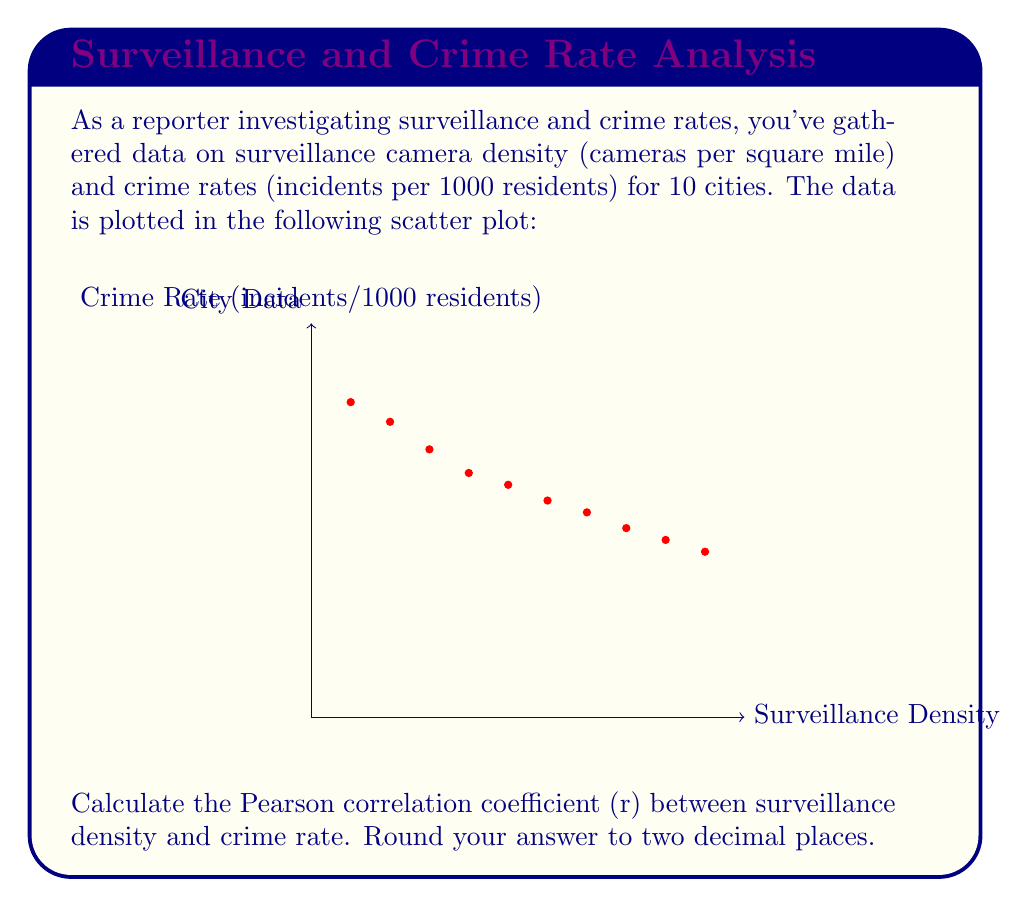Can you answer this question? To calculate the Pearson correlation coefficient (r), we'll use the formula:

$$ r = \frac{\sum_{i=1}^{n} (x_i - \bar{x})(y_i - \bar{y})}{\sqrt{\sum_{i=1}^{n} (x_i - \bar{x})^2} \sqrt{\sum_{i=1}^{n} (y_i - \bar{y})^2}} $$

Where:
$x_i$ = surveillance density values
$y_i$ = crime rate values
$\bar{x}$ = mean of surveillance density
$\bar{y}$ = mean of crime rate
$n$ = number of data points (10 in this case)

Step 1: Calculate means
$\bar{x} = \frac{5+10+15+20+25+30+35+40+45+50}{10} = 27.5$
$\bar{y} = \frac{8+7.5+6.8+6.2+5.9+5.5+5.2+4.8+4.5+4.2}{10} = 5.86$

Step 2: Calculate $(x_i - \bar{x})$, $(y_i - \bar{y})$, $(x_i - \bar{x})^2$, $(y_i - \bar{y})^2$, and $(x_i - \bar{x})(y_i - \bar{y})$ for each data point.

Step 3: Sum up the values calculated in step 2:
$\sum (x_i - \bar{x})(y_i - \bar{y}) = -412.25$
$\sum (x_i - \bar{x})^2 = 4125$
$\sum (y_i - \bar{y})^2 = 11.854$

Step 4: Apply the formula:

$$ r = \frac{-412.25}{\sqrt{4125} \sqrt{11.854}} = -0.9759 $$

Step 5: Round to two decimal places: -0.98
Answer: -0.98 